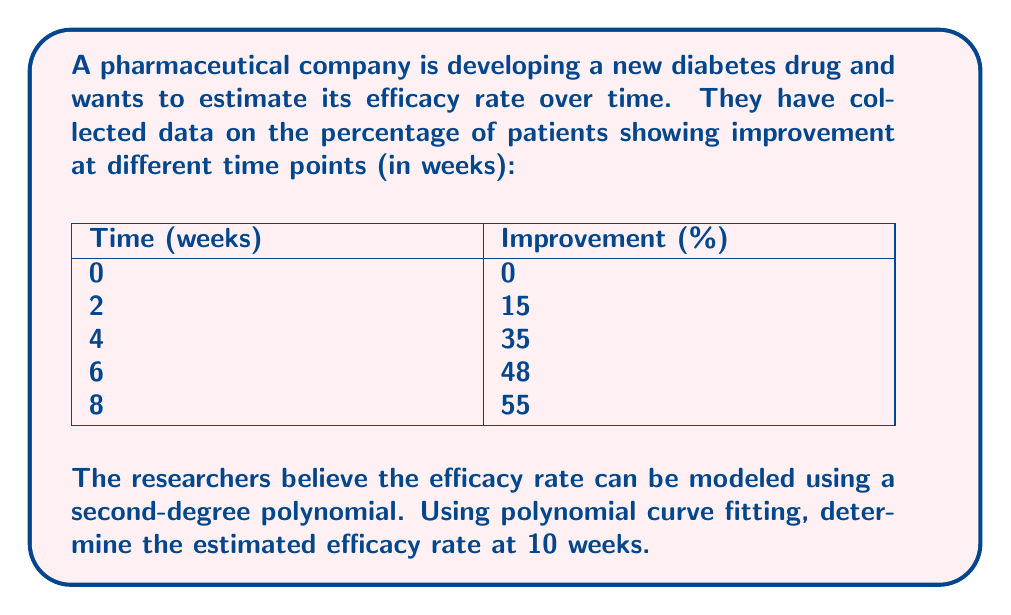Show me your answer to this math problem. To solve this problem, we'll use polynomial curve fitting with a second-degree polynomial. The steps are as follows:

1) We assume the polynomial has the form:

   $$ y = ax^2 + bx + c $$

   where $y$ is the improvement percentage and $x$ is the time in weeks.

2) We need to solve for $a$, $b$, and $c$ using the given data points. This typically involves solving a system of normal equations or using matrix operations. For simplicity, we'll use a polynomial regression calculator.

3) Using a polynomial regression calculator with the given data points, we get the following equation:

   $$ y = -0.625x^2 + 13.375x + 1.5 $$

4) To estimate the efficacy rate at 10 weeks, we substitute $x = 10$ into our equation:

   $$ y = -0.625(10)^2 + 13.375(10) + 1.5 $$
   $$ y = -0.625(100) + 133.75 + 1.5 $$
   $$ y = -62.5 + 133.75 + 1.5 $$
   $$ y = 72.75 $$

5) Therefore, the estimated efficacy rate at 10 weeks is 72.75%.

Note: In practice, it's important to assess the fit of the model and consider confidence intervals. This simple calculation provides a point estimate based on the given data and model.
Answer: 72.75% 